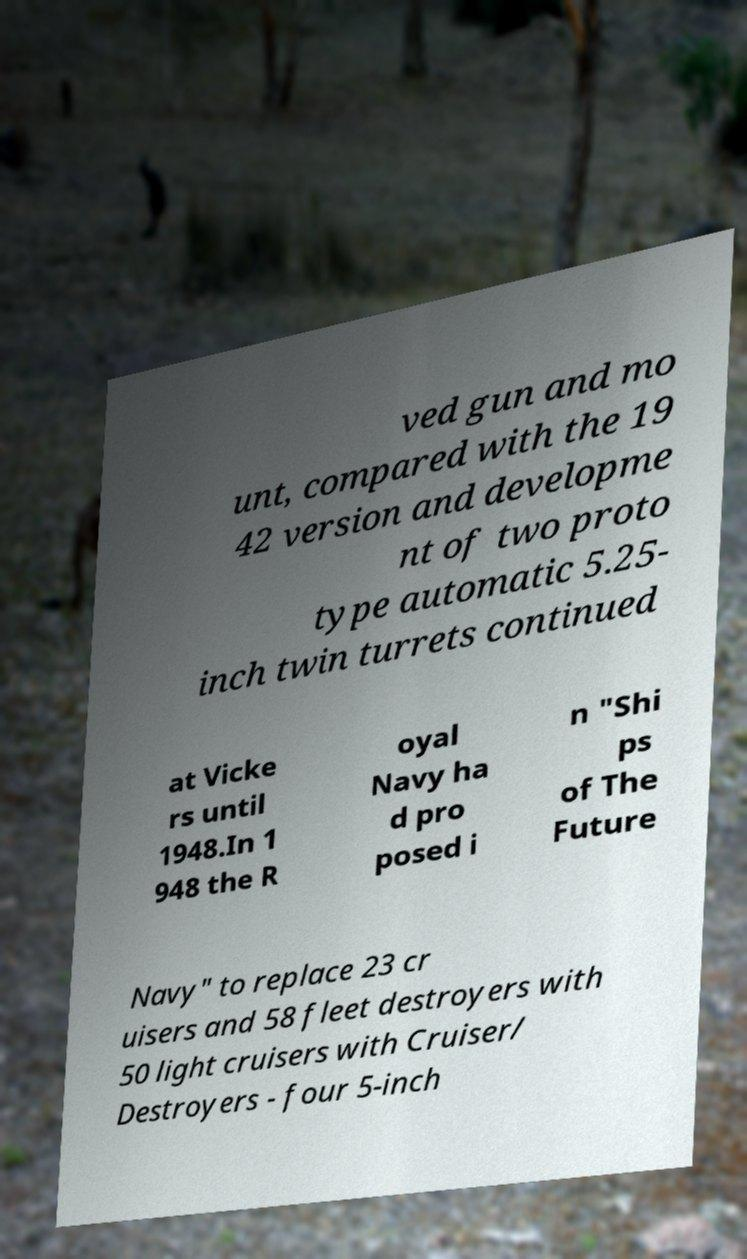Please identify and transcribe the text found in this image. ved gun and mo unt, compared with the 19 42 version and developme nt of two proto type automatic 5.25- inch twin turrets continued at Vicke rs until 1948.In 1 948 the R oyal Navy ha d pro posed i n "Shi ps of The Future Navy" to replace 23 cr uisers and 58 fleet destroyers with 50 light cruisers with Cruiser/ Destroyers - four 5-inch 